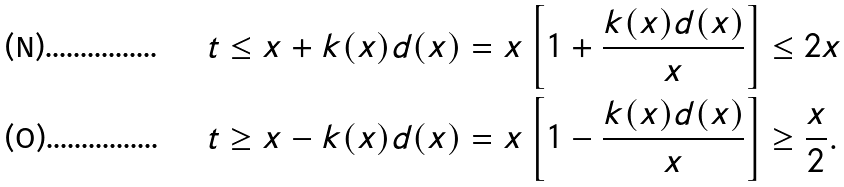Convert formula to latex. <formula><loc_0><loc_0><loc_500><loc_500>& t \leq x + k ( x ) d ( x ) = x \left [ 1 + \frac { k ( x ) d ( x ) } { x } \right ] \leq 2 x \\ & t \geq x - k ( x ) d ( x ) = x \left [ 1 - \frac { k ( x ) d ( x ) } { x } \right ] \geq \frac { x } { 2 } .</formula> 